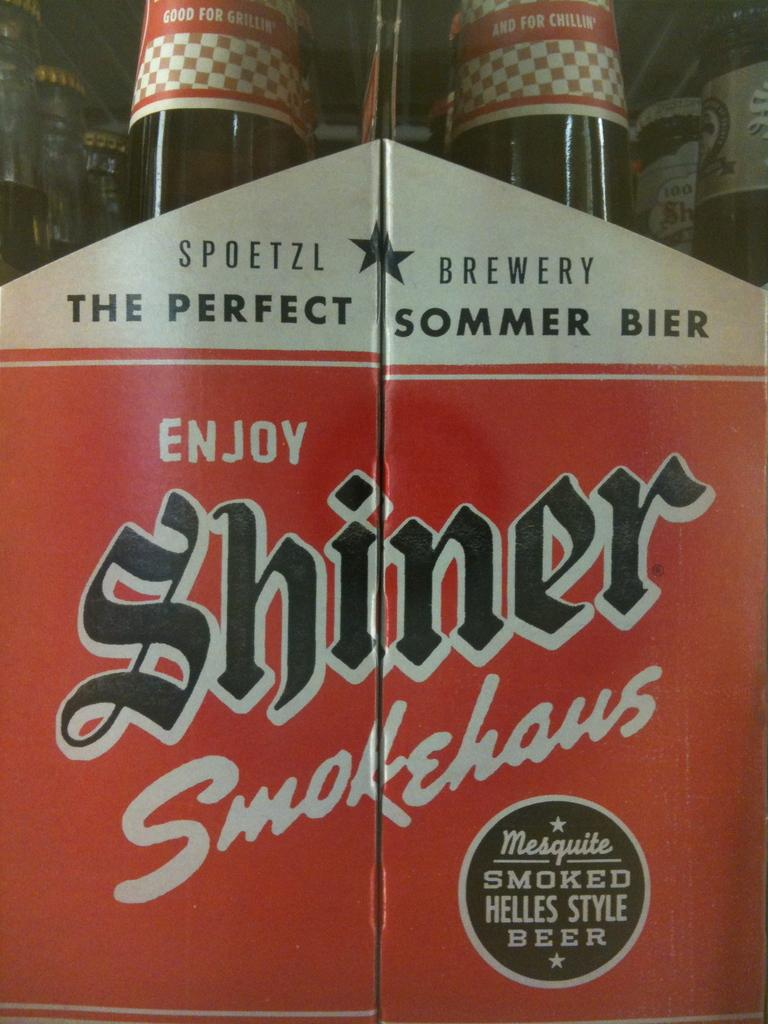<image>
Present a compact description of the photo's key features. The red and white packaging for Shiner Smokehaus craft beer. 